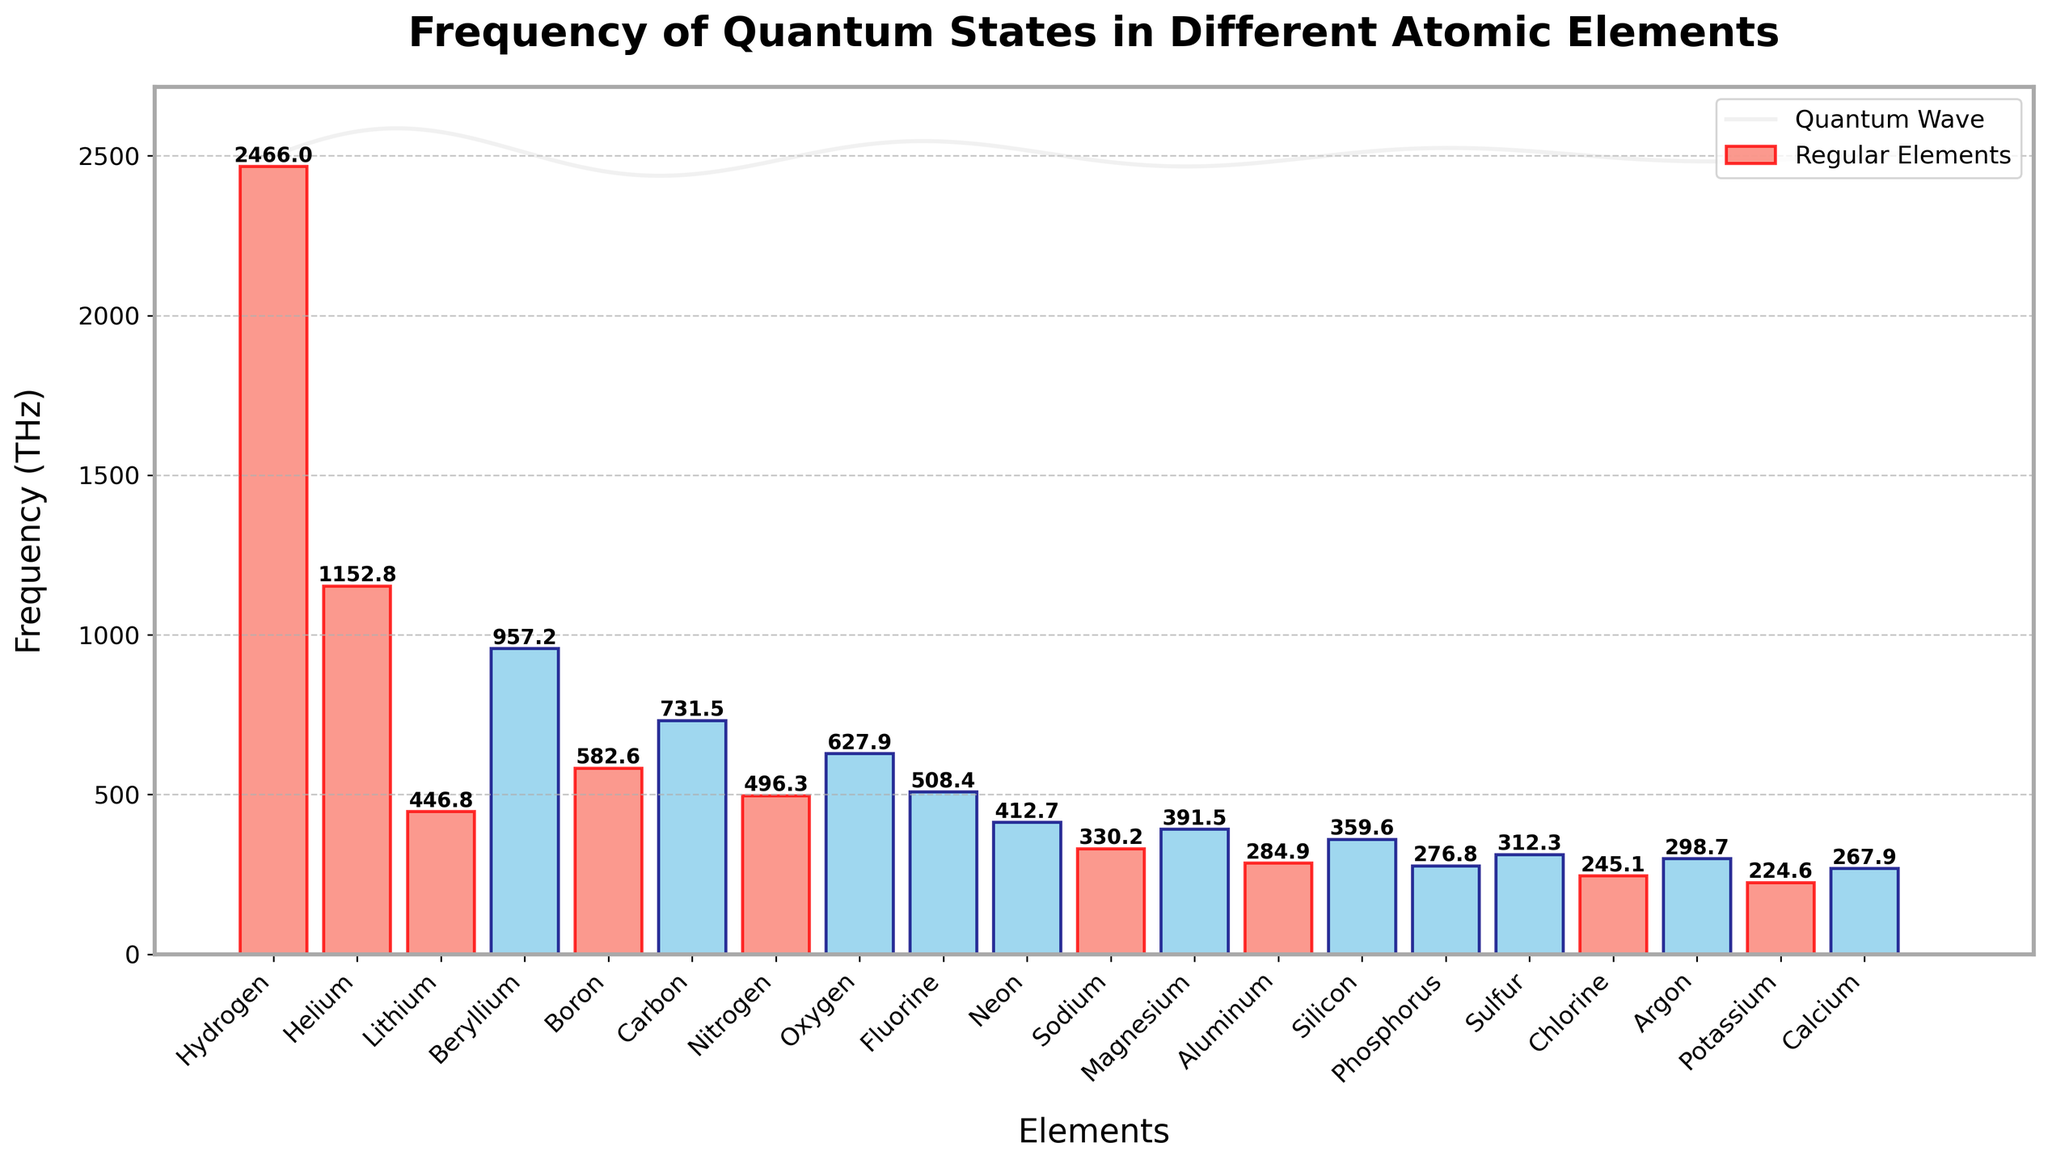Which element has the highest quantum state frequency? The element with the highest bar in the bar chart represents the highest quantum state frequency. In this case, it is Hydrogen with a frequency of 2466.0 THz.
Answer: Hydrogen How many elements have a quantum state frequency lower than 400 THz? By visually inspecting the heights of the bars, we see that Neon, Sodium, Aluminum, Silicon, Phosphorus, and Potassium have frequencies lower than 400 THz. Counting them gives us six elements: Neon, Sodium, Aluminum, Silicon, Phosphorus, and Potassium.
Answer: 6 Which prime-numbered element has the highest frequency? Highlighted bars in salmon represent the prime-numbered elements. Among these, Hydrogen has the highest bar, indicating the highest frequency among prime-numbered elements.
Answer: Hydrogen What is the frequency difference between Fluorine and Neon? Find the bar heights for Fluorine and Neon, which are 508.4 THz and 412.7 THz, respectively. The difference is 508.4 - 412.7 = 95.7 THz.
Answer: 95.7 THz Which elements have a quantum state frequency between 500 THz and 1000 THz? By examining the heights of the bars, Nitrogen, Beryllium, Boron, Carbon, and Fluorine fall within this range. Their frequencies are 496.3 THz, 957.2 THz, 582.6 THz, 731.5 THz, and 508.4 THz.
Answer: Nitrogen, Beryllium, Boron, Carbon, Fluorine What is the average frequency of the prime-numbered elements? Prime-numbered elements are Hydrogen (2466.0 THz), Helium (1152.8 THz), Lithium (446.8 THz), Boron (582.6 THz), Nitrogen (496.3 THz), Sodium (330.2 THz), Aluminum (284.9 THz), Chlorine (245.1 THz), and Calcium (267.9 THz). Summing these gives 6282.6 THz. There are 9 elements, so the average frequency is 6282.6 / 9 ≈ 698.1 THz.
Answer: 698.1 THz Which non-prime element has the lowest quantum state frequency? Non-prime elements are highlighted in sky blue. Among these, by comparing the heights of the bars, Potassium has the lowest frequency at 224.6 THz.
Answer: Potassium What is the combined frequency of Beryllium and Carbon? From the figure, the frequencies for Beryllium and Carbon are 957.2 THz and 731.5 THz, respectively. Adding them gives 957.2 + 731.5 = 1688.7 THz.
Answer: 1688.7 THz Which element has a higher frequency, Oxygen or Nitrogen? Compare the heights of the bars for Oxygen and Nitrogen. Oxygen has a frequency of 627.9 THz, while Nitrogen has a frequency of 496.3 THz. Thus, Oxygen has a higher frequency.
Answer: Oxygen 